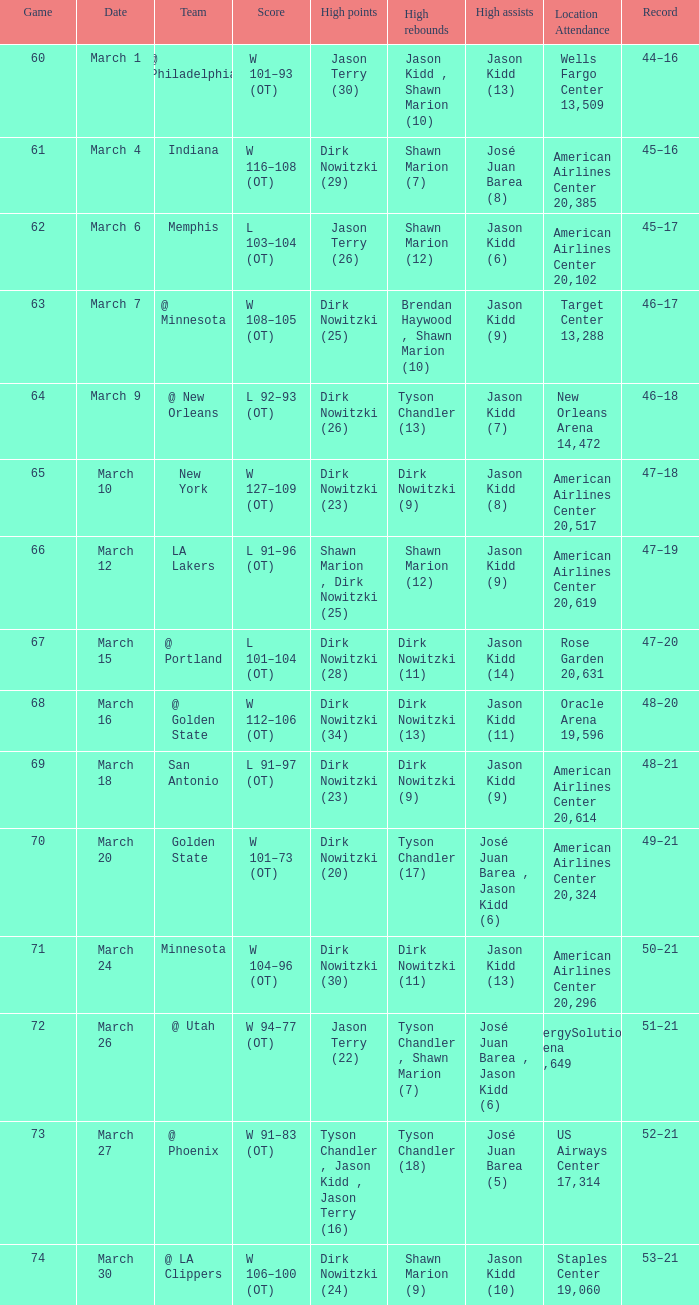Name the score for  josé juan barea (8) W 116–108 (OT). Would you be able to parse every entry in this table? {'header': ['Game', 'Date', 'Team', 'Score', 'High points', 'High rebounds', 'High assists', 'Location Attendance', 'Record'], 'rows': [['60', 'March 1', '@ Philadelphia', 'W 101–93 (OT)', 'Jason Terry (30)', 'Jason Kidd , Shawn Marion (10)', 'Jason Kidd (13)', 'Wells Fargo Center 13,509', '44–16'], ['61', 'March 4', 'Indiana', 'W 116–108 (OT)', 'Dirk Nowitzki (29)', 'Shawn Marion (7)', 'José Juan Barea (8)', 'American Airlines Center 20,385', '45–16'], ['62', 'March 6', 'Memphis', 'L 103–104 (OT)', 'Jason Terry (26)', 'Shawn Marion (12)', 'Jason Kidd (6)', 'American Airlines Center 20,102', '45–17'], ['63', 'March 7', '@ Minnesota', 'W 108–105 (OT)', 'Dirk Nowitzki (25)', 'Brendan Haywood , Shawn Marion (10)', 'Jason Kidd (9)', 'Target Center 13,288', '46–17'], ['64', 'March 9', '@ New Orleans', 'L 92–93 (OT)', 'Dirk Nowitzki (26)', 'Tyson Chandler (13)', 'Jason Kidd (7)', 'New Orleans Arena 14,472', '46–18'], ['65', 'March 10', 'New York', 'W 127–109 (OT)', 'Dirk Nowitzki (23)', 'Dirk Nowitzki (9)', 'Jason Kidd (8)', 'American Airlines Center 20,517', '47–18'], ['66', 'March 12', 'LA Lakers', 'L 91–96 (OT)', 'Shawn Marion , Dirk Nowitzki (25)', 'Shawn Marion (12)', 'Jason Kidd (9)', 'American Airlines Center 20,619', '47–19'], ['67', 'March 15', '@ Portland', 'L 101–104 (OT)', 'Dirk Nowitzki (28)', 'Dirk Nowitzki (11)', 'Jason Kidd (14)', 'Rose Garden 20,631', '47–20'], ['68', 'March 16', '@ Golden State', 'W 112–106 (OT)', 'Dirk Nowitzki (34)', 'Dirk Nowitzki (13)', 'Jason Kidd (11)', 'Oracle Arena 19,596', '48–20'], ['69', 'March 18', 'San Antonio', 'L 91–97 (OT)', 'Dirk Nowitzki (23)', 'Dirk Nowitzki (9)', 'Jason Kidd (9)', 'American Airlines Center 20,614', '48–21'], ['70', 'March 20', 'Golden State', 'W 101–73 (OT)', 'Dirk Nowitzki (20)', 'Tyson Chandler (17)', 'José Juan Barea , Jason Kidd (6)', 'American Airlines Center 20,324', '49–21'], ['71', 'March 24', 'Minnesota', 'W 104–96 (OT)', 'Dirk Nowitzki (30)', 'Dirk Nowitzki (11)', 'Jason Kidd (13)', 'American Airlines Center 20,296', '50–21'], ['72', 'March 26', '@ Utah', 'W 94–77 (OT)', 'Jason Terry (22)', 'Tyson Chandler , Shawn Marion (7)', 'José Juan Barea , Jason Kidd (6)', 'EnergySolutions Arena 19,649', '51–21'], ['73', 'March 27', '@ Phoenix', 'W 91–83 (OT)', 'Tyson Chandler , Jason Kidd , Jason Terry (16)', 'Tyson Chandler (18)', 'José Juan Barea (5)', 'US Airways Center 17,314', '52–21'], ['74', 'March 30', '@ LA Clippers', 'W 106–100 (OT)', 'Dirk Nowitzki (24)', 'Shawn Marion (9)', 'Jason Kidd (10)', 'Staples Center 19,060', '53–21']]} 